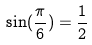<formula> <loc_0><loc_0><loc_500><loc_500>\sin ( \frac { \pi } { 6 } ) = \frac { 1 } { 2 }</formula> 